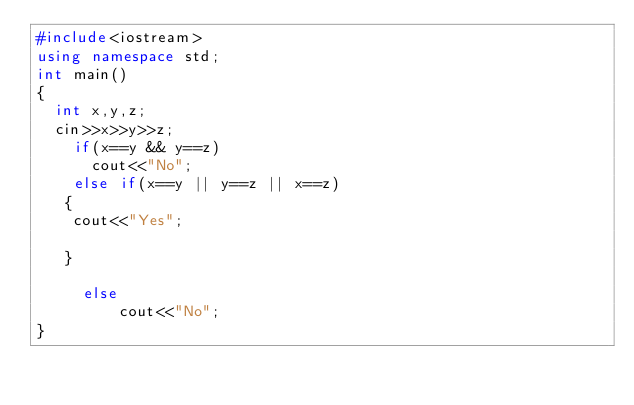Convert code to text. <code><loc_0><loc_0><loc_500><loc_500><_C++_>#include<iostream>
using namespace std;
int main()
{
	int x,y,z;
	cin>>x>>y>>z;
	  if(x==y && y==z)
	    cout<<"No";
    else if(x==y || y==z || x==z)
	 {
	 	cout<<"Yes";
	 	
	 }

     else
         cout<<"No";
}</code> 